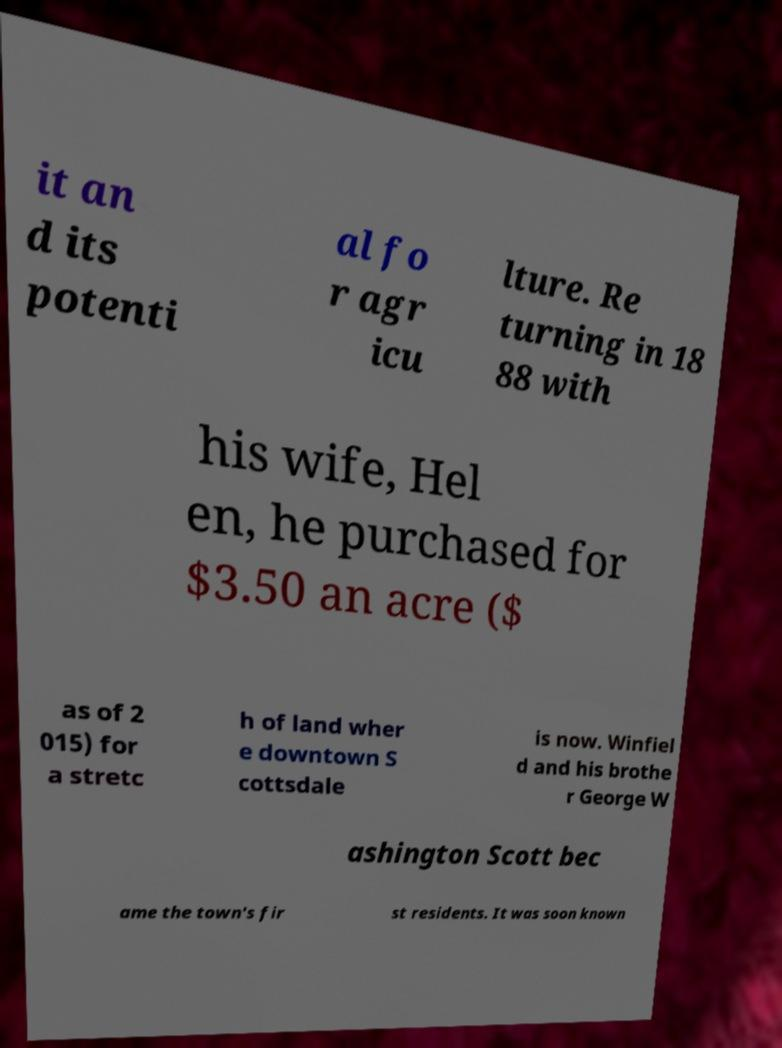Please identify and transcribe the text found in this image. it an d its potenti al fo r agr icu lture. Re turning in 18 88 with his wife, Hel en, he purchased for $3.50 an acre ($ as of 2 015) for a stretc h of land wher e downtown S cottsdale is now. Winfiel d and his brothe r George W ashington Scott bec ame the town's fir st residents. It was soon known 